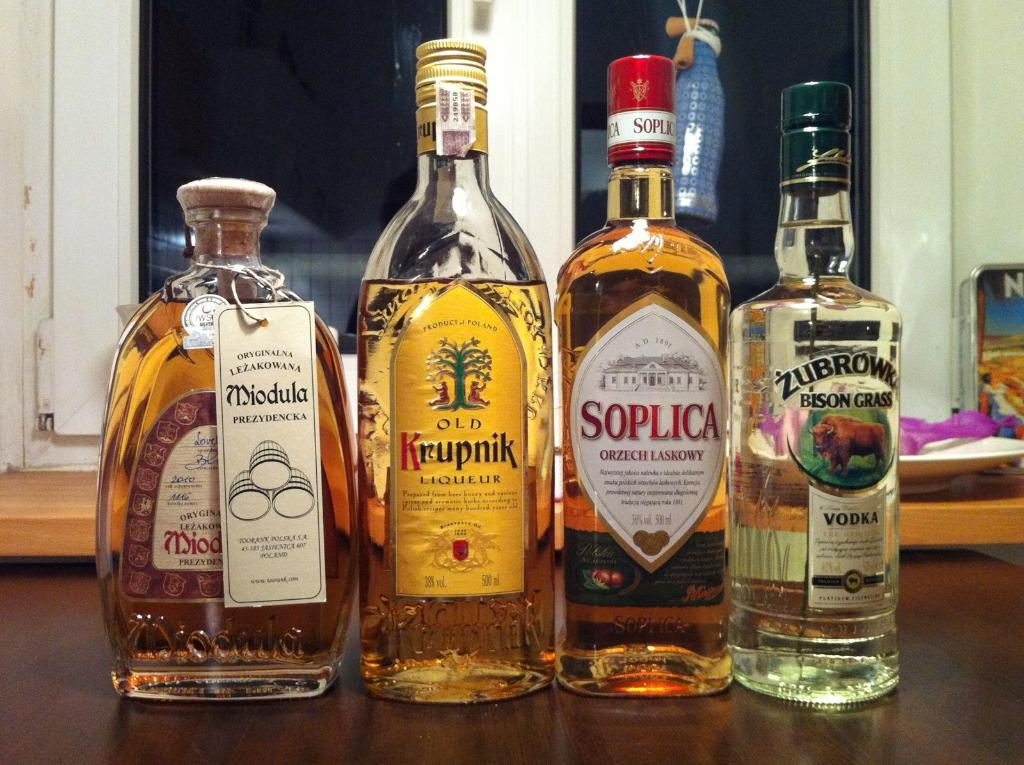<image>
Render a clear and concise summary of the photo. A table demonstrating four different vodka liquor bottles of various sizes. 